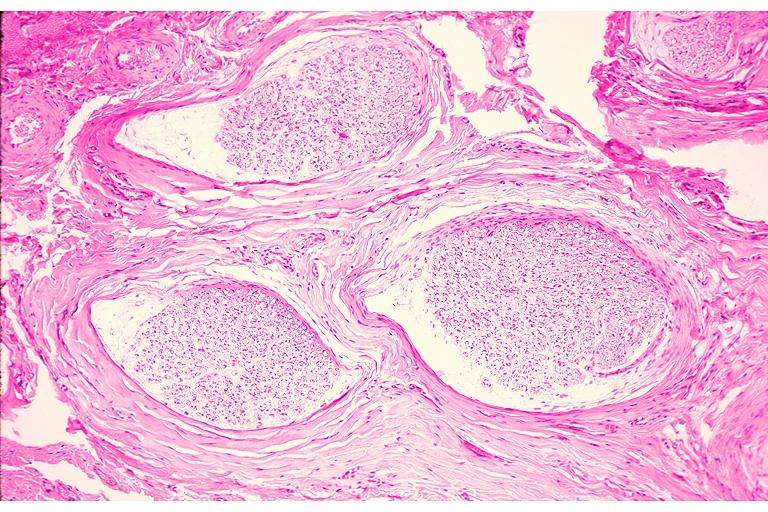s oral present?
Answer the question using a single word or phrase. Yes 